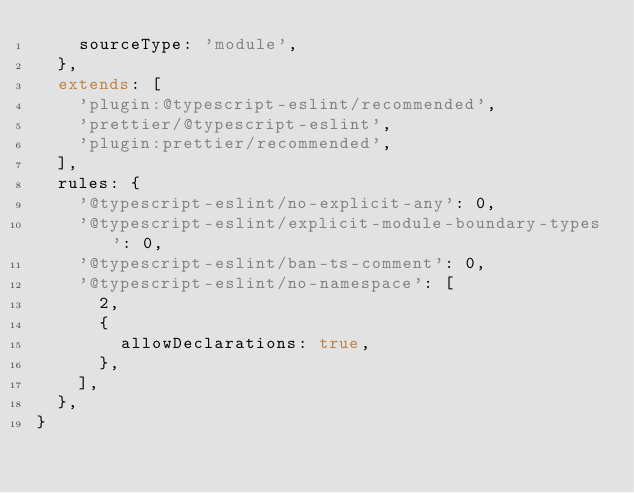Convert code to text. <code><loc_0><loc_0><loc_500><loc_500><_JavaScript_>    sourceType: 'module',
  },
  extends: [
    'plugin:@typescript-eslint/recommended',
    'prettier/@typescript-eslint',
    'plugin:prettier/recommended',
  ],
  rules: {
    '@typescript-eslint/no-explicit-any': 0,
    '@typescript-eslint/explicit-module-boundary-types': 0,
    '@typescript-eslint/ban-ts-comment': 0,
    '@typescript-eslint/no-namespace': [
      2,
      {
        allowDeclarations: true,
      },
    ],
  },
}
</code> 